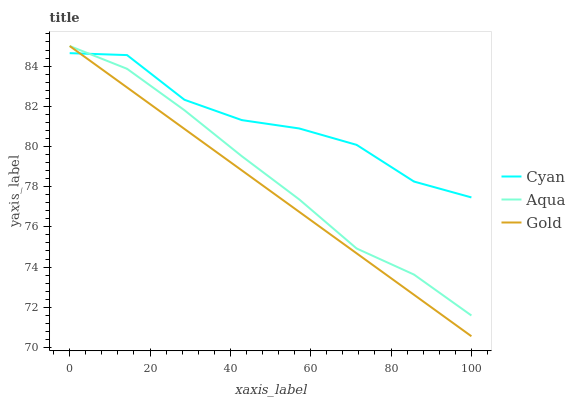Does Gold have the minimum area under the curve?
Answer yes or no. Yes. Does Cyan have the maximum area under the curve?
Answer yes or no. Yes. Does Aqua have the minimum area under the curve?
Answer yes or no. No. Does Aqua have the maximum area under the curve?
Answer yes or no. No. Is Gold the smoothest?
Answer yes or no. Yes. Is Cyan the roughest?
Answer yes or no. Yes. Is Aqua the smoothest?
Answer yes or no. No. Is Aqua the roughest?
Answer yes or no. No. Does Gold have the lowest value?
Answer yes or no. Yes. Does Aqua have the lowest value?
Answer yes or no. No. Does Gold have the highest value?
Answer yes or no. Yes. Does Aqua intersect Cyan?
Answer yes or no. Yes. Is Aqua less than Cyan?
Answer yes or no. No. Is Aqua greater than Cyan?
Answer yes or no. No. 